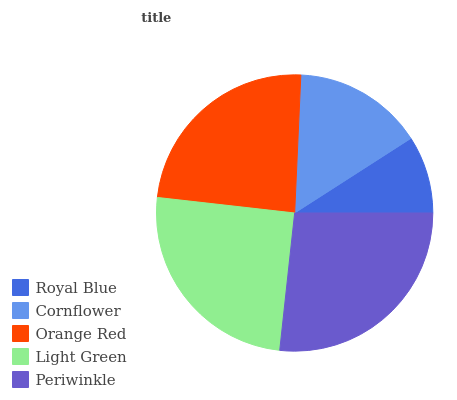Is Royal Blue the minimum?
Answer yes or no. Yes. Is Periwinkle the maximum?
Answer yes or no. Yes. Is Cornflower the minimum?
Answer yes or no. No. Is Cornflower the maximum?
Answer yes or no. No. Is Cornflower greater than Royal Blue?
Answer yes or no. Yes. Is Royal Blue less than Cornflower?
Answer yes or no. Yes. Is Royal Blue greater than Cornflower?
Answer yes or no. No. Is Cornflower less than Royal Blue?
Answer yes or no. No. Is Orange Red the high median?
Answer yes or no. Yes. Is Orange Red the low median?
Answer yes or no. Yes. Is Cornflower the high median?
Answer yes or no. No. Is Light Green the low median?
Answer yes or no. No. 